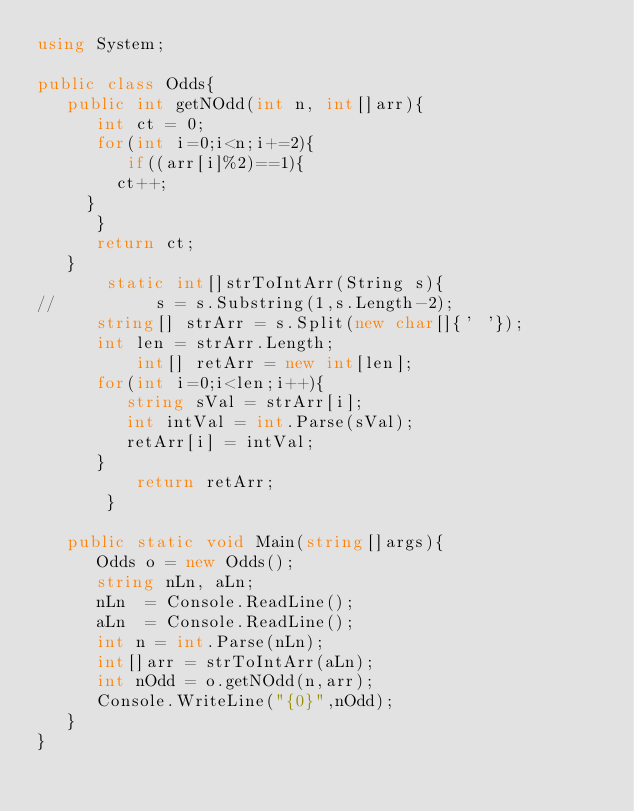Convert code to text. <code><loc_0><loc_0><loc_500><loc_500><_C#_>using System;

public class Odds{
   public int getNOdd(int n, int[]arr){
      int ct = 0;
      for(int i=0;i<n;i+=2){
         if((arr[i]%2)==1){
	    ct++;
	 }
      }
      return ct;
   }
       static int[]strToIntArr(String s){
//          s = s.Substring(1,s.Length-2);
	  string[] strArr = s.Split(new char[]{' '});
	  int len = strArr.Length;
          int[] retArr = new int[len];       
	  for(int i=0;i<len;i++){
	     string sVal = strArr[i];
	     int intVal = int.Parse(sVal);
	     retArr[i] = intVal;
	  }
          return retArr;
       }
       
   public static void Main(string[]args){
      Odds o = new Odds();
      string nLn, aLn;
      nLn  = Console.ReadLine();
      aLn  = Console.ReadLine();
      int n = int.Parse(nLn);
      int[]arr = strToIntArr(aLn);
      int nOdd = o.getNOdd(n,arr);
      Console.WriteLine("{0}",nOdd);
   }
}</code> 